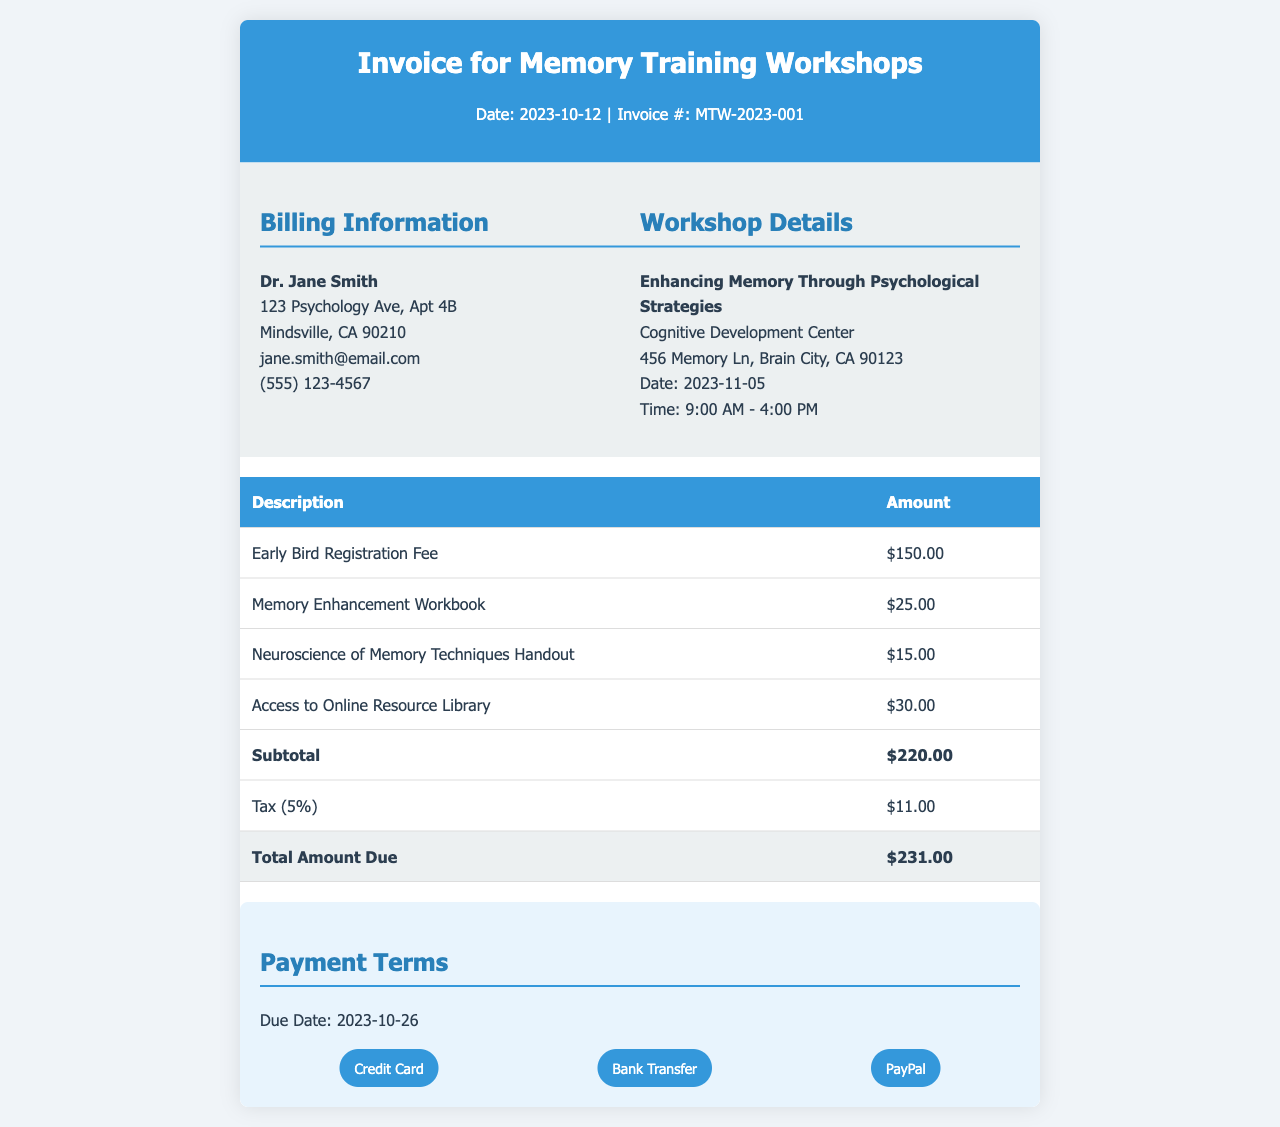What is the date of the invoice? The date of the invoice is clearly stated in the header section as the day the document was created.
Answer: 2023-10-12 Who is the invoice billed to? The billing information section details the name of the individual or organization being billed.
Answer: Dr. Jane Smith What is the total amount due? The total amount due is calculated at the bottom of the invoice, summarizing all costs after tax.
Answer: $231.00 When is the payment due? The due date for payment is specified in the payment terms section of the document.
Answer: 2023-10-26 How much is the early bird registration fee? The breakdown of charges includes a specific fee for early registration, which is listed in the table.
Answer: $150.00 What materials are included with the workshop? The invoice lists all materials provided with the workshop, summarizing the contents of the training package.
Answer: Memory Enhancement Workbook, Neuroscience of Memory Techniques Handout, Access to Online Resource Library What is the subtotal before tax? The subtotal represents the total amount for services and materials before tax is applied.
Answer: $220.00 What tax percentage is applied? The invoice specifies the tax rate used to calculate the total amount due, which is indicated next to the tax line.
Answer: 5% What is the name of the workshop? The workshop details section includes the specific title of the workshop being invoiced.
Answer: Enhancing Memory Through Psychological Strategies 